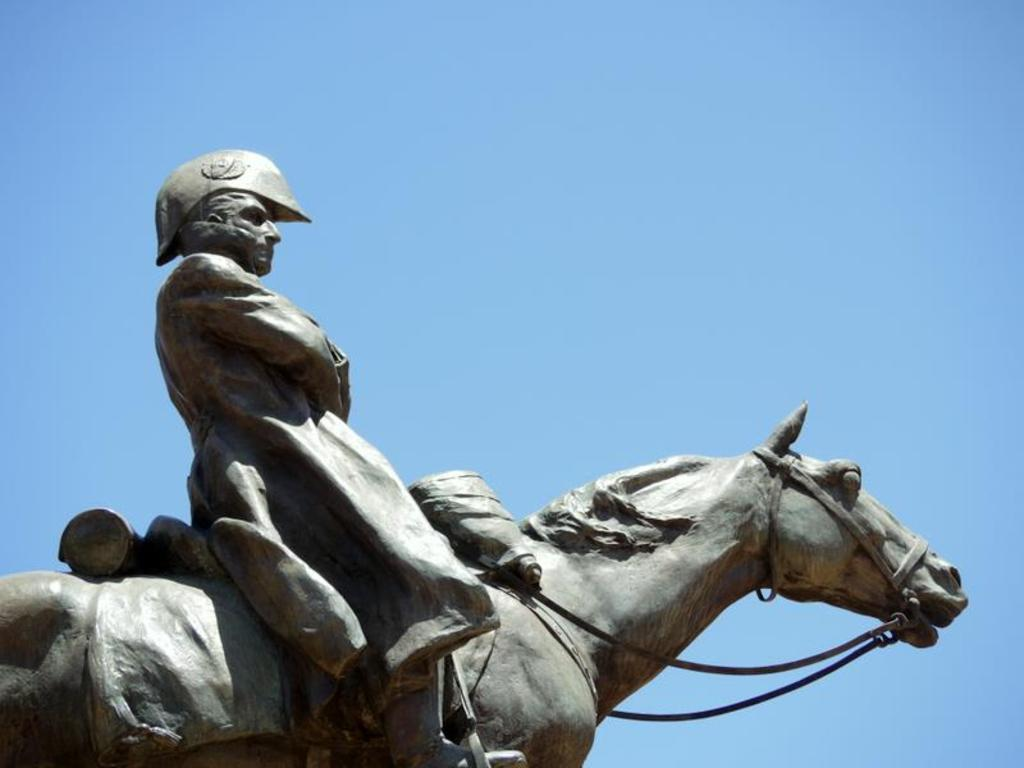What is the main subject in the image? There is a statue in the image. What can be seen on the backside of the statue? The sky is visible on the backside of the statue. How many buttons are on the statue in the image? There are no buttons present on the statue in the image. What type of clocks can be seen on the statue in the image? There are no clocks present on the statue in the image. 